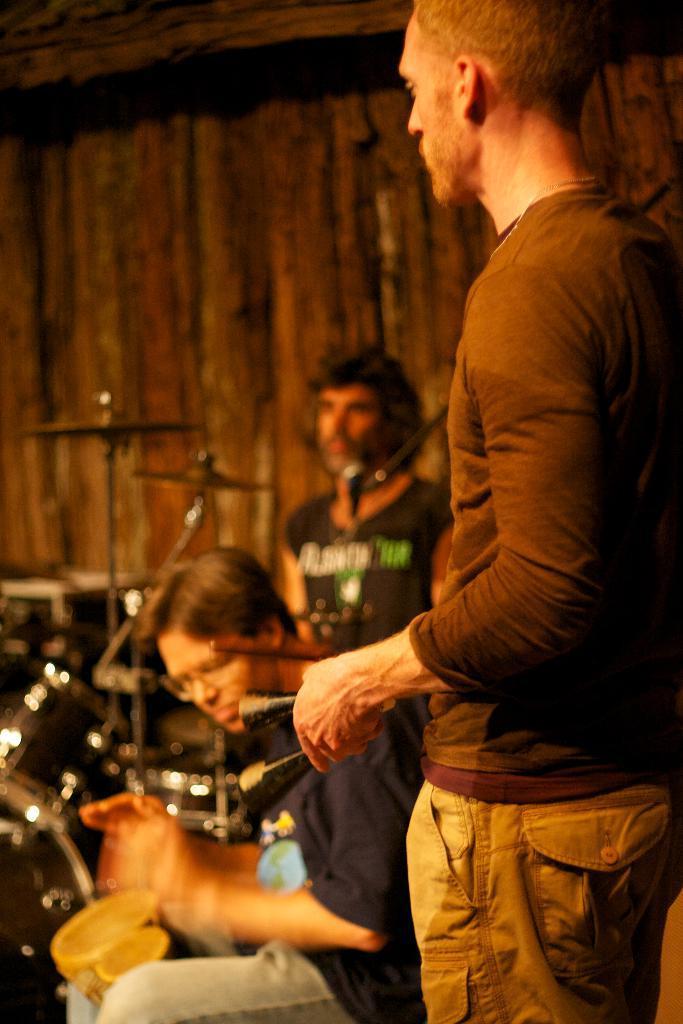How would you summarize this image in a sentence or two? In the picture there are three musicians playing drums and tabla. 